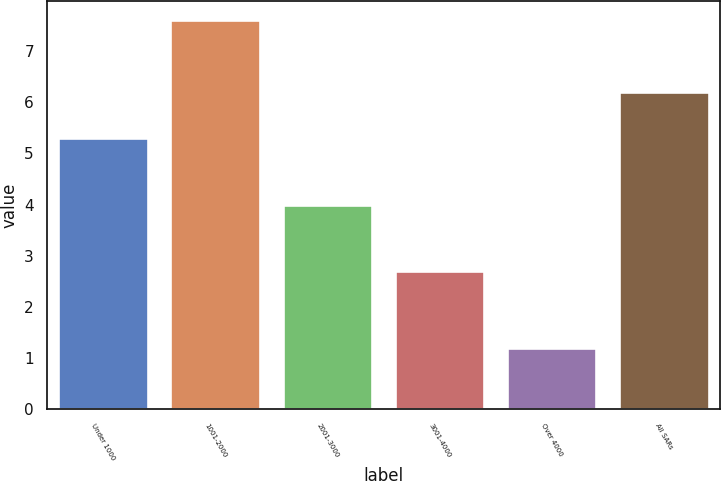Convert chart to OTSL. <chart><loc_0><loc_0><loc_500><loc_500><bar_chart><fcel>Under 1000<fcel>1001-2000<fcel>2001-3000<fcel>3001-4000<fcel>Over 4000<fcel>All SARs<nl><fcel>5.3<fcel>7.6<fcel>4<fcel>2.7<fcel>1.2<fcel>6.2<nl></chart> 